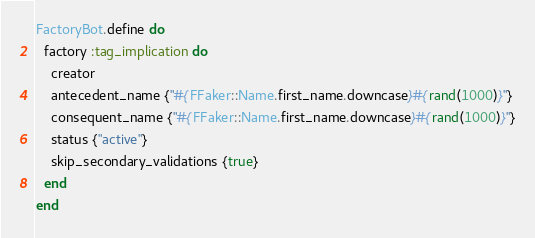<code> <loc_0><loc_0><loc_500><loc_500><_Ruby_>FactoryBot.define do
  factory :tag_implication do
    creator
    antecedent_name {"#{FFaker::Name.first_name.downcase}#{rand(1000)}"}
    consequent_name {"#{FFaker::Name.first_name.downcase}#{rand(1000)}"}
    status {"active"}
    skip_secondary_validations {true}
  end
end
</code> 